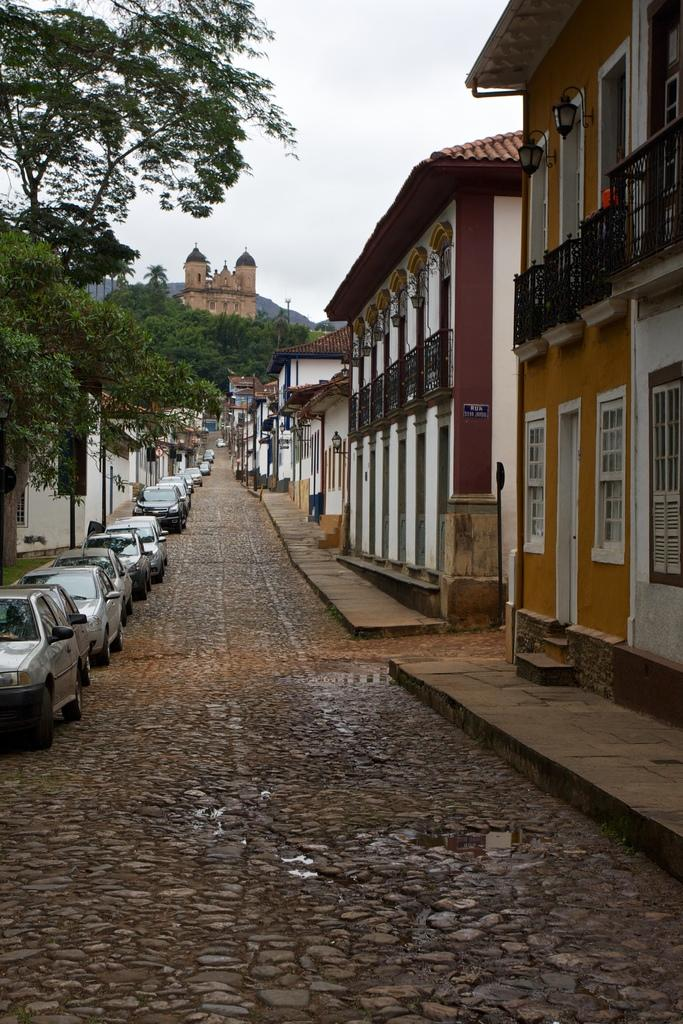What type of view is depicted in the image? The image contains a street view. What can be seen on the street in the image? There are cars parked on the street. What type of vegetation is present on either side of the street? There are trees on either side of the street. What type of structures are present on either side of the street? There are buildings on either side of the street. How many beads are hanging from the trees in the image? There are no beads present in the image; it features a street view with trees and buildings. What type of rings can be seen on the girl's fingers in the image? There is no girl present in the image, so no rings can be observed. 